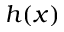Convert formula to latex. <formula><loc_0><loc_0><loc_500><loc_500>h ( x )</formula> 